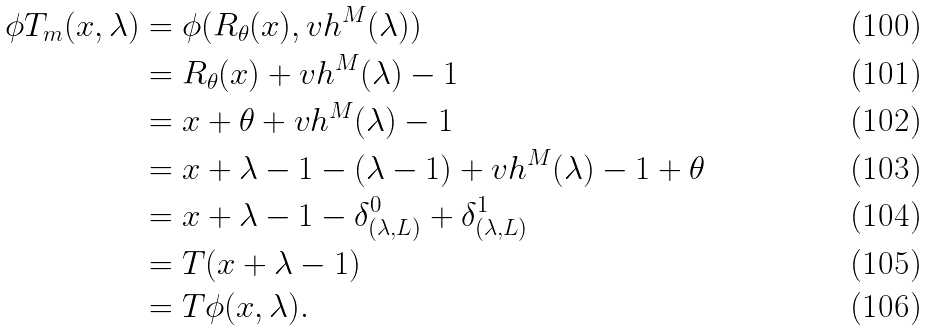<formula> <loc_0><loc_0><loc_500><loc_500>\phi T _ { m } ( x , \lambda ) & = \phi ( R _ { \theta } ( x ) , v h ^ { M } ( \lambda ) ) \\ & = R _ { \theta } ( x ) + v h ^ { M } ( \lambda ) - 1 \\ & = x + \theta + v h ^ { M } ( \lambda ) - 1 \\ & = x + \lambda - 1 - ( \lambda - 1 ) + v h ^ { M } ( \lambda ) - 1 + \theta \\ & = x + \lambda - 1 - \delta _ { ( \lambda , L ) } ^ { 0 } + \delta _ { ( \lambda , L ) } ^ { 1 } \\ & = T ( x + \lambda - 1 ) \\ & = T \phi ( x , \lambda ) .</formula> 